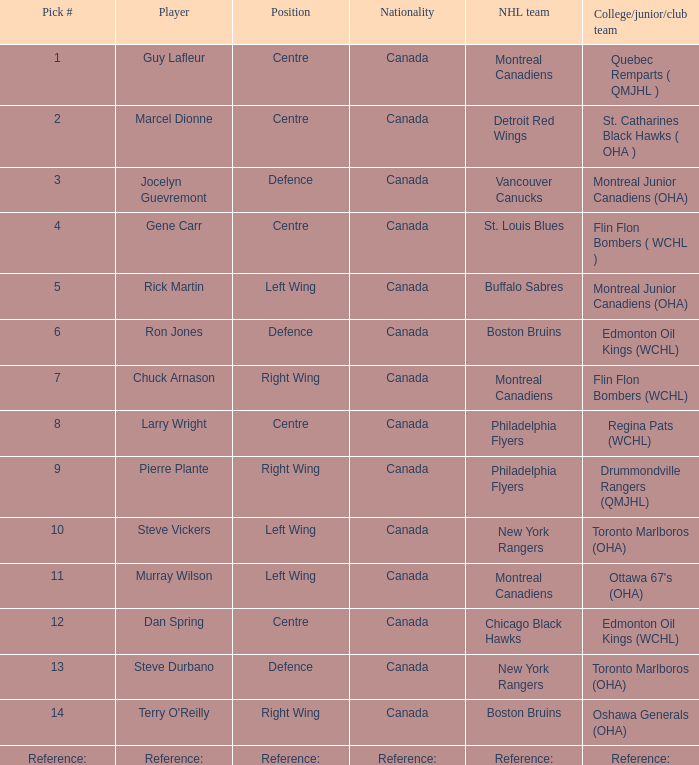Which NHL team has a Player of steve durbano? New York Rangers. 